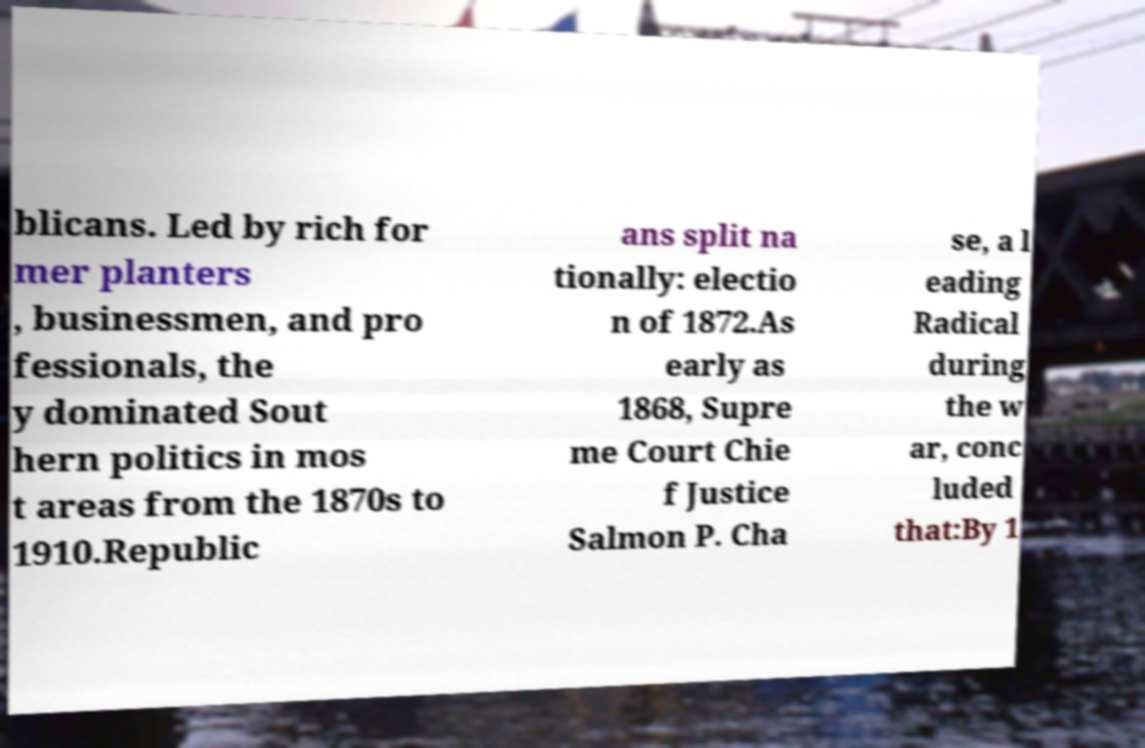Could you extract and type out the text from this image? blicans. Led by rich for mer planters , businessmen, and pro fessionals, the y dominated Sout hern politics in mos t areas from the 1870s to 1910.Republic ans split na tionally: electio n of 1872.As early as 1868, Supre me Court Chie f Justice Salmon P. Cha se, a l eading Radical during the w ar, conc luded that:By 1 